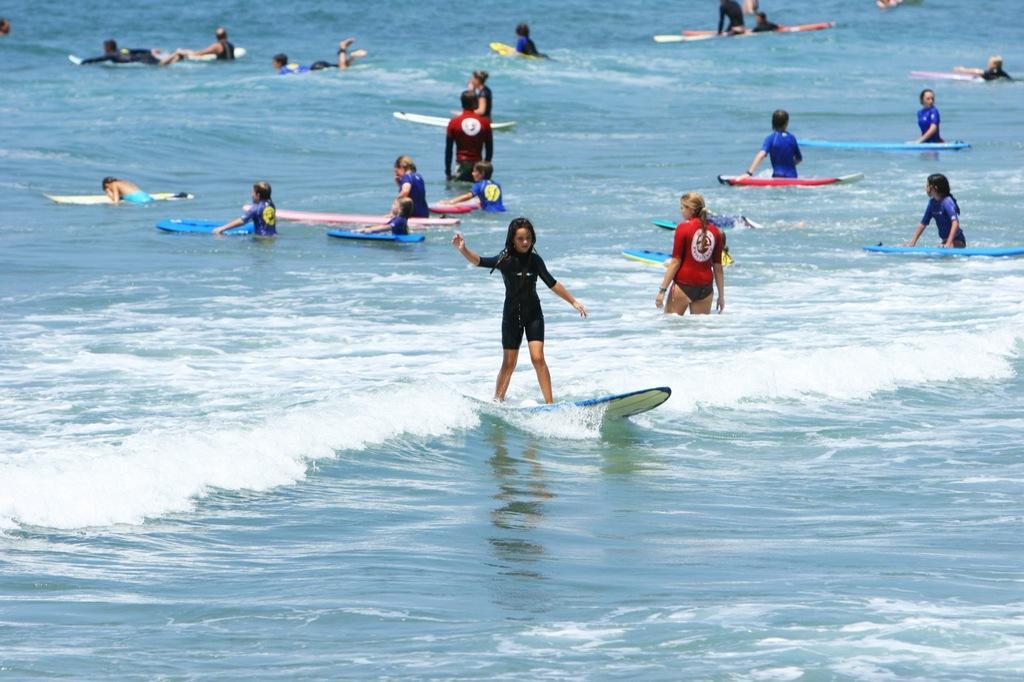Can you describe this image briefly? This image is taken outdoors. At the bottom of the image there is a sea with waves. In the middle of the image a girl is surfing on the sea with a surfing board. In the background a few people are trying to surf on the sea with surfing boards. 